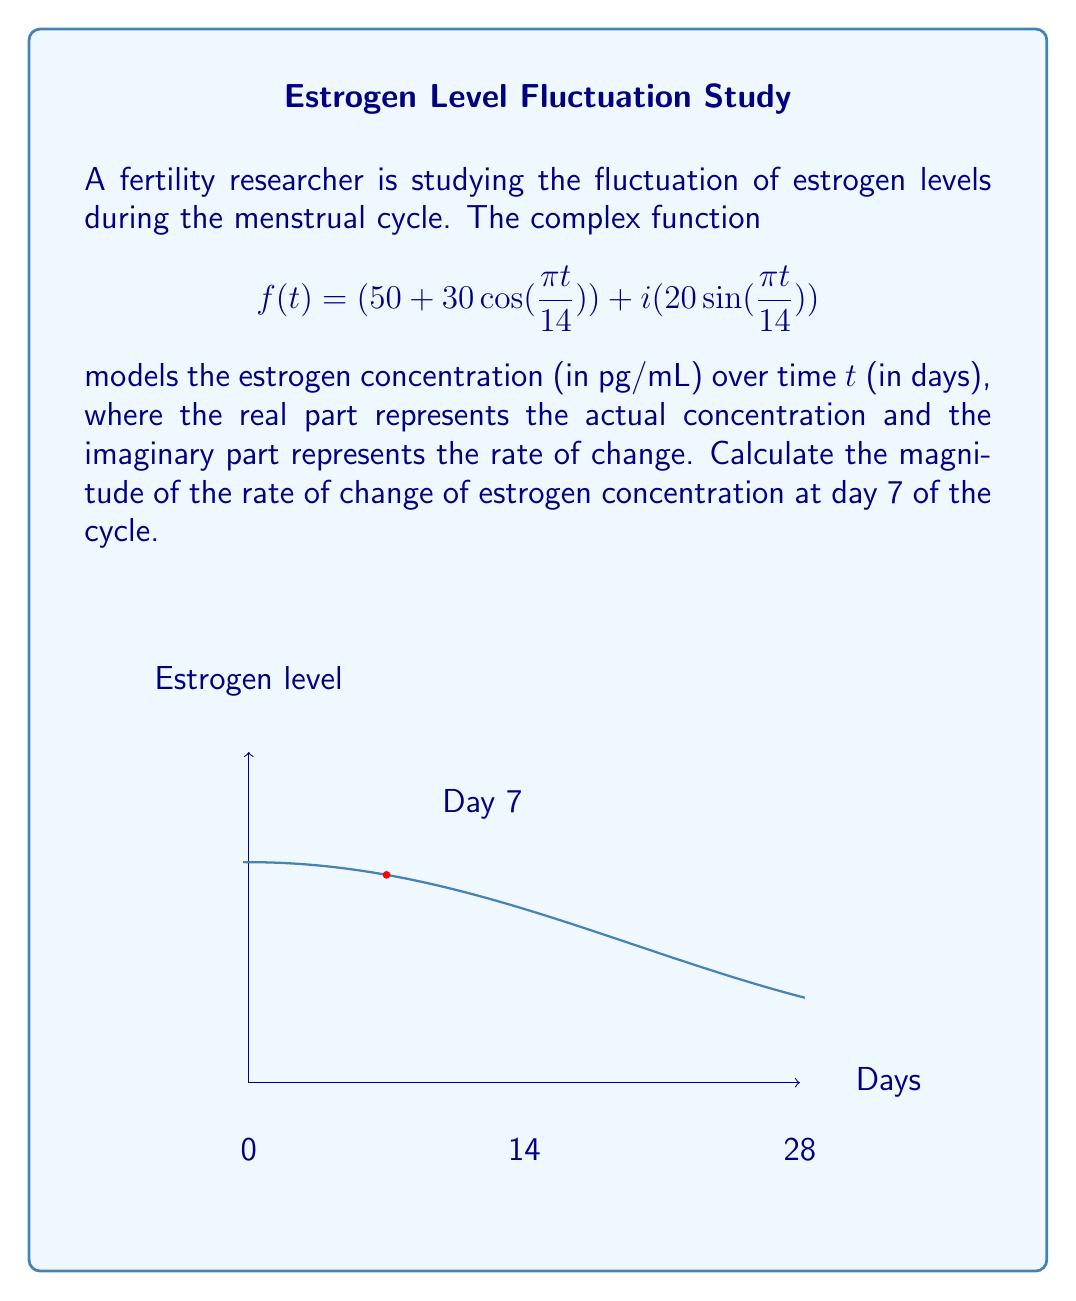Can you solve this math problem? Let's approach this step-by-step:

1) The given complex function is:
   $$f(t) = (50 + 30\cos(\frac{\pi t}{14})) + i(20\sin(\frac{\pi t}{14}))$$

2) The imaginary part represents the rate of change. So we focus on:
   $$20\sin(\frac{\pi t}{14})$$

3) To find the magnitude of the rate of change at day 7, we need to calculate:
   $$|20\sin(\frac{\pi \cdot 7}{14})|$$

4) Let's solve the inside of the sine function first:
   $$\frac{\pi \cdot 7}{14} = \frac{\pi}{2}$$

5) Now our expression becomes:
   $$|20\sin(\frac{\pi}{2})|$$

6) We know that $\sin(\frac{\pi}{2}) = 1$, so:
   $$|20 \cdot 1| = 20$$

7) The absolute value of a positive number is the number itself, so our final answer is 20.

This means the magnitude of the rate of change of estrogen concentration at day 7 is 20 pg/mL per day.
Answer: 20 pg/mL per day 